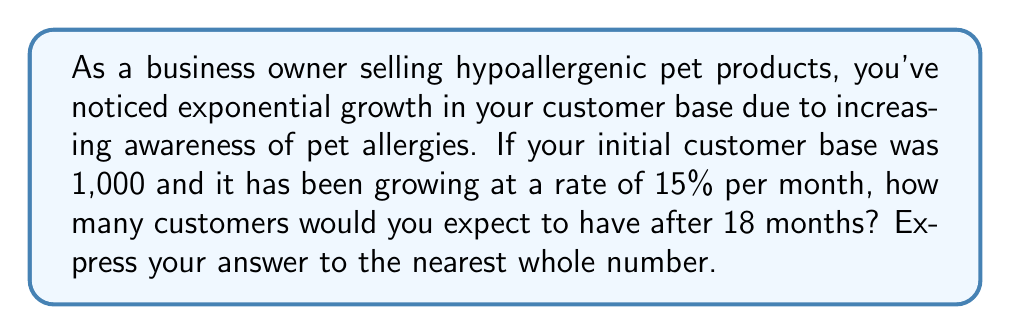Help me with this question. Let's approach this step-by-step using an exponential growth function:

1) The general form of an exponential growth function is:

   $$A(t) = A_0(1 + r)^t$$

   Where:
   $A(t)$ is the amount after time $t$
   $A_0$ is the initial amount
   $r$ is the growth rate (as a decimal)
   $t$ is the time period

2) In this problem:
   $A_0 = 1,000$ (initial customer base)
   $r = 0.15$ (15% monthly growth rate)
   $t = 18$ (months)

3) Plugging these values into our equation:

   $$A(18) = 1,000(1 + 0.15)^{18}$$

4) Simplify:
   $$A(18) = 1,000(1.15)^{18}$$

5) Calculate:
   $$A(18) = 1,000 * 13.0069...$$
   $$A(18) = 13,006.9...$$

6) Rounding to the nearest whole number:
   $$A(18) \approx 13,007$$

Therefore, after 18 months, you would expect to have approximately 13,007 customers.
Answer: 13,007 customers 